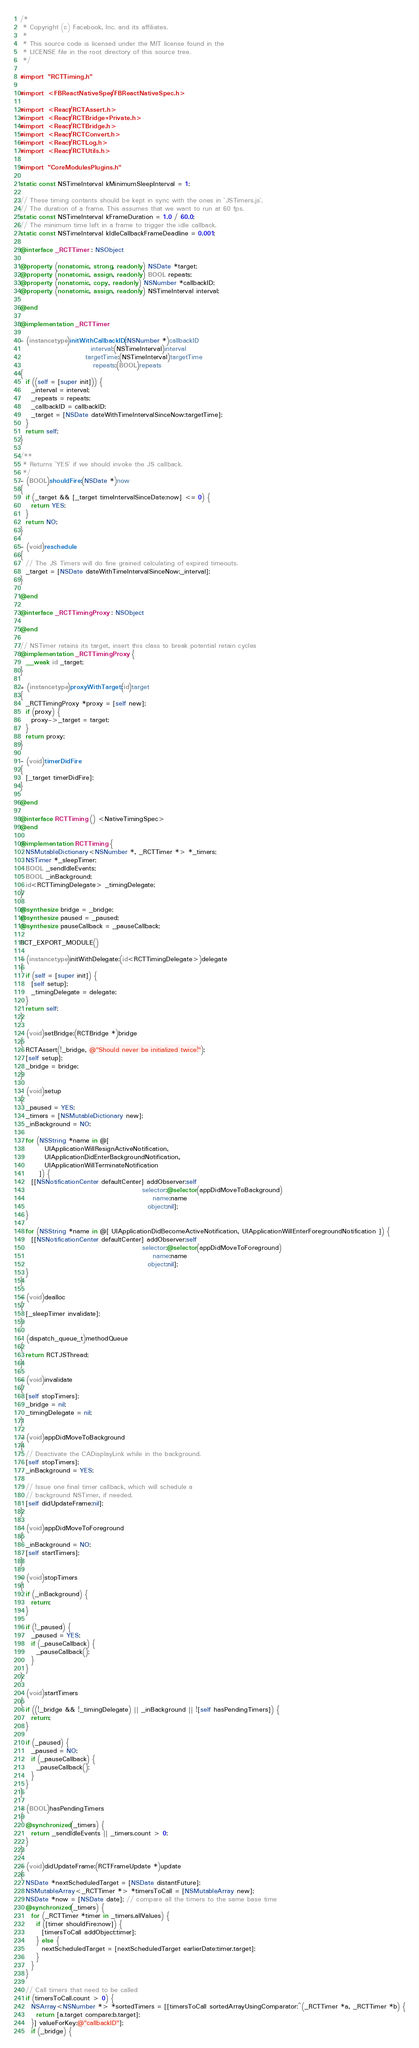<code> <loc_0><loc_0><loc_500><loc_500><_ObjectiveC_>/*
 * Copyright (c) Facebook, Inc. and its affiliates.
 *
 * This source code is licensed under the MIT license found in the
 * LICENSE file in the root directory of this source tree.
 */

#import "RCTTiming.h"

#import <FBReactNativeSpec/FBReactNativeSpec.h>

#import <React/RCTAssert.h>
#import <React/RCTBridge+Private.h>
#import <React/RCTBridge.h>
#import <React/RCTConvert.h>
#import <React/RCTLog.h>
#import <React/RCTUtils.h>

#import "CoreModulesPlugins.h"

static const NSTimeInterval kMinimumSleepInterval = 1;

// These timing contants should be kept in sync with the ones in `JSTimers.js`.
// The duration of a frame. This assumes that we want to run at 60 fps.
static const NSTimeInterval kFrameDuration = 1.0 / 60.0;
// The minimum time left in a frame to trigger the idle callback.
static const NSTimeInterval kIdleCallbackFrameDeadline = 0.001;

@interface _RCTTimer : NSObject

@property (nonatomic, strong, readonly) NSDate *target;
@property (nonatomic, assign, readonly) BOOL repeats;
@property (nonatomic, copy, readonly) NSNumber *callbackID;
@property (nonatomic, assign, readonly) NSTimeInterval interval;

@end

@implementation _RCTTimer

- (instancetype)initWithCallbackID:(NSNumber *)callbackID
                          interval:(NSTimeInterval)interval
                        targetTime:(NSTimeInterval)targetTime
                           repeats:(BOOL)repeats
{
  if ((self = [super init])) {
    _interval = interval;
    _repeats = repeats;
    _callbackID = callbackID;
    _target = [NSDate dateWithTimeIntervalSinceNow:targetTime];
  }
  return self;
}

/**
 * Returns `YES` if we should invoke the JS callback.
 */
- (BOOL)shouldFire:(NSDate *)now
{
  if (_target && [_target timeIntervalSinceDate:now] <= 0) {
    return YES;
  }
  return NO;
}

- (void)reschedule
{
  // The JS Timers will do fine grained calculating of expired timeouts.
  _target = [NSDate dateWithTimeIntervalSinceNow:_interval];
}

@end

@interface _RCTTimingProxy : NSObject

@end

// NSTimer retains its target, insert this class to break potential retain cycles
@implementation _RCTTimingProxy {
  __weak id _target;
}

+ (instancetype)proxyWithTarget:(id)target
{
  _RCTTimingProxy *proxy = [self new];
  if (proxy) {
    proxy->_target = target;
  }
  return proxy;
}

- (void)timerDidFire
{
  [_target timerDidFire];
}

@end

@interface RCTTiming () <NativeTimingSpec>
@end

@implementation RCTTiming {
  NSMutableDictionary<NSNumber *, _RCTTimer *> *_timers;
  NSTimer *_sleepTimer;
  BOOL _sendIdleEvents;
  BOOL _inBackground;
  id<RCTTimingDelegate> _timingDelegate;
}

@synthesize bridge = _bridge;
@synthesize paused = _paused;
@synthesize pauseCallback = _pauseCallback;

RCT_EXPORT_MODULE()

- (instancetype)initWithDelegate:(id<RCTTimingDelegate>)delegate
{
  if (self = [super init]) {
    [self setup];
    _timingDelegate = delegate;
  }
  return self;
}

- (void)setBridge:(RCTBridge *)bridge
{
  RCTAssert(!_bridge, @"Should never be initialized twice!");
  [self setup];
  _bridge = bridge;
}

- (void)setup
{
  _paused = YES;
  _timers = [NSMutableDictionary new];
  _inBackground = NO;

  for (NSString *name in @[
         UIApplicationWillResignActiveNotification,
         UIApplicationDidEnterBackgroundNotification,
         UIApplicationWillTerminateNotification
       ]) {
    [[NSNotificationCenter defaultCenter] addObserver:self
                                             selector:@selector(appDidMoveToBackground)
                                                 name:name
                                               object:nil];
  }

  for (NSString *name in @[ UIApplicationDidBecomeActiveNotification, UIApplicationWillEnterForegroundNotification ]) {
    [[NSNotificationCenter defaultCenter] addObserver:self
                                             selector:@selector(appDidMoveToForeground)
                                                 name:name
                                               object:nil];
  }
}

- (void)dealloc
{
  [_sleepTimer invalidate];
}

- (dispatch_queue_t)methodQueue
{
  return RCTJSThread;
}

- (void)invalidate
{
  [self stopTimers];
  _bridge = nil;
  _timingDelegate = nil;
}

- (void)appDidMoveToBackground
{
  // Deactivate the CADisplayLink while in the background.
  [self stopTimers];
  _inBackground = YES;

  // Issue one final timer callback, which will schedule a
  // background NSTimer, if needed.
  [self didUpdateFrame:nil];
}

- (void)appDidMoveToForeground
{
  _inBackground = NO;
  [self startTimers];
}

- (void)stopTimers
{
  if (_inBackground) {
    return;
  }

  if (!_paused) {
    _paused = YES;
    if (_pauseCallback) {
      _pauseCallback();
    }
  }
}

- (void)startTimers
{
  if ((!_bridge && !_timingDelegate) || _inBackground || ![self hasPendingTimers]) {
    return;
  }

  if (_paused) {
    _paused = NO;
    if (_pauseCallback) {
      _pauseCallback();
    }
  }
}

- (BOOL)hasPendingTimers
{
  @synchronized(_timers) {
    return _sendIdleEvents || _timers.count > 0;
  }
}

- (void)didUpdateFrame:(RCTFrameUpdate *)update
{
  NSDate *nextScheduledTarget = [NSDate distantFuture];
  NSMutableArray<_RCTTimer *> *timersToCall = [NSMutableArray new];
  NSDate *now = [NSDate date]; // compare all the timers to the same base time
  @synchronized(_timers) {
    for (_RCTTimer *timer in _timers.allValues) {
      if ([timer shouldFire:now]) {
        [timersToCall addObject:timer];
      } else {
        nextScheduledTarget = [nextScheduledTarget earlierDate:timer.target];
      }
    }
  }

  // Call timers that need to be called
  if (timersToCall.count > 0) {
    NSArray<NSNumber *> *sortedTimers = [[timersToCall sortedArrayUsingComparator:^(_RCTTimer *a, _RCTTimer *b) {
      return [a.target compare:b.target];
    }] valueForKey:@"callbackID"];
    if (_bridge) {</code> 